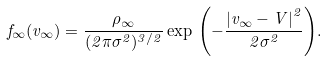Convert formula to latex. <formula><loc_0><loc_0><loc_500><loc_500>f _ { \infty } ( { v } _ { \infty } ) = \frac { \rho _ { \infty } } { ( 2 \pi \sigma ^ { 2 } ) ^ { 3 / 2 } } \exp \, { \left ( - { \frac { \left | { v } _ { \infty } - { V } \right | ^ { 2 } } { 2 \sigma ^ { 2 } } } \right ) } .</formula> 